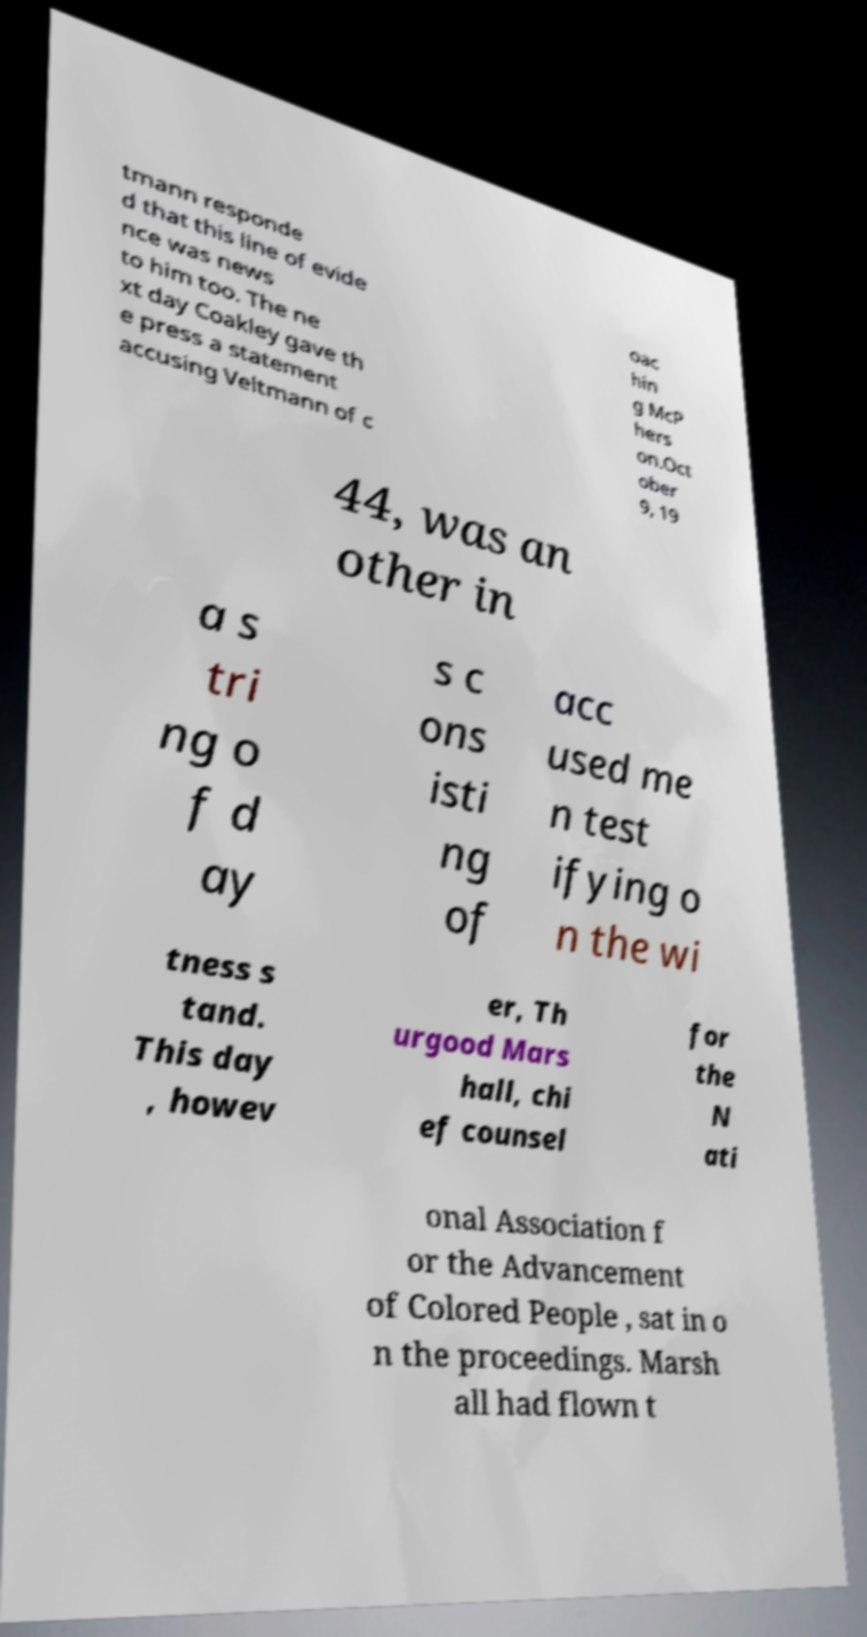Please identify and transcribe the text found in this image. tmann responde d that this line of evide nce was news to him too. The ne xt day Coakley gave th e press a statement accusing Veltmann of c oac hin g McP hers on.Oct ober 9, 19 44, was an other in a s tri ng o f d ay s c ons isti ng of acc used me n test ifying o n the wi tness s tand. This day , howev er, Th urgood Mars hall, chi ef counsel for the N ati onal Association f or the Advancement of Colored People , sat in o n the proceedings. Marsh all had flown t 